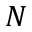Convert formula to latex. <formula><loc_0><loc_0><loc_500><loc_500>N</formula> 